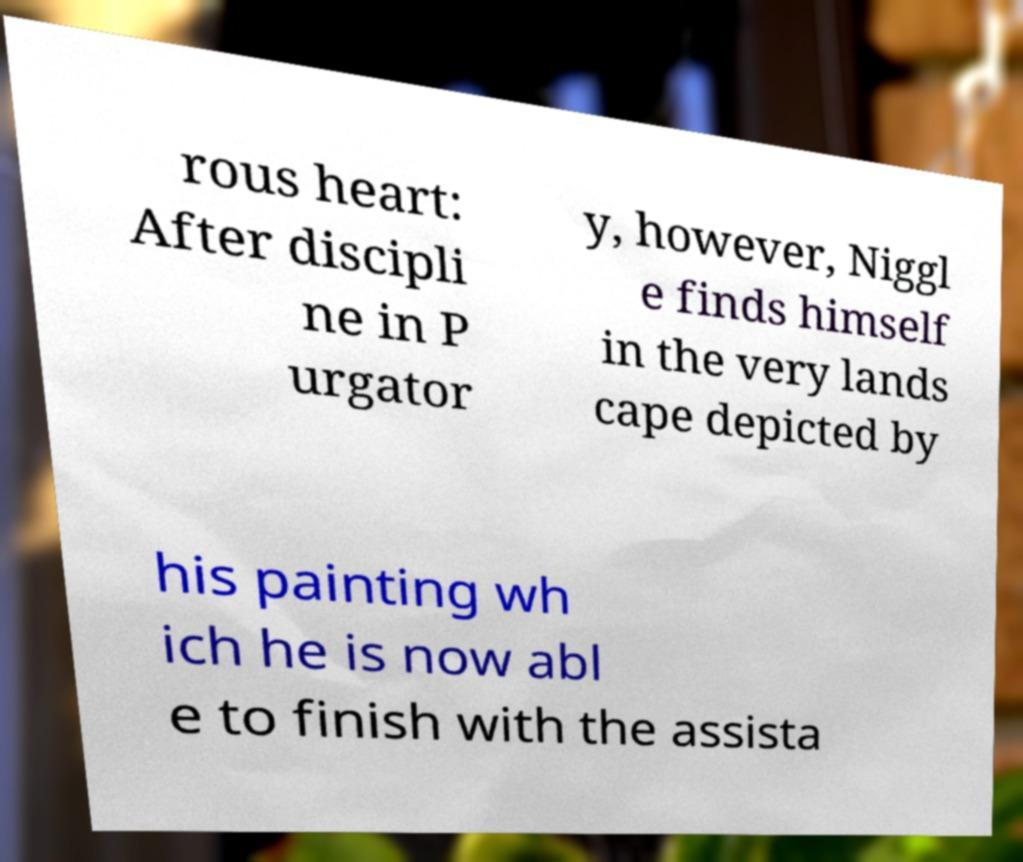For documentation purposes, I need the text within this image transcribed. Could you provide that? rous heart: After discipli ne in P urgator y, however, Niggl e finds himself in the very lands cape depicted by his painting wh ich he is now abl e to finish with the assista 